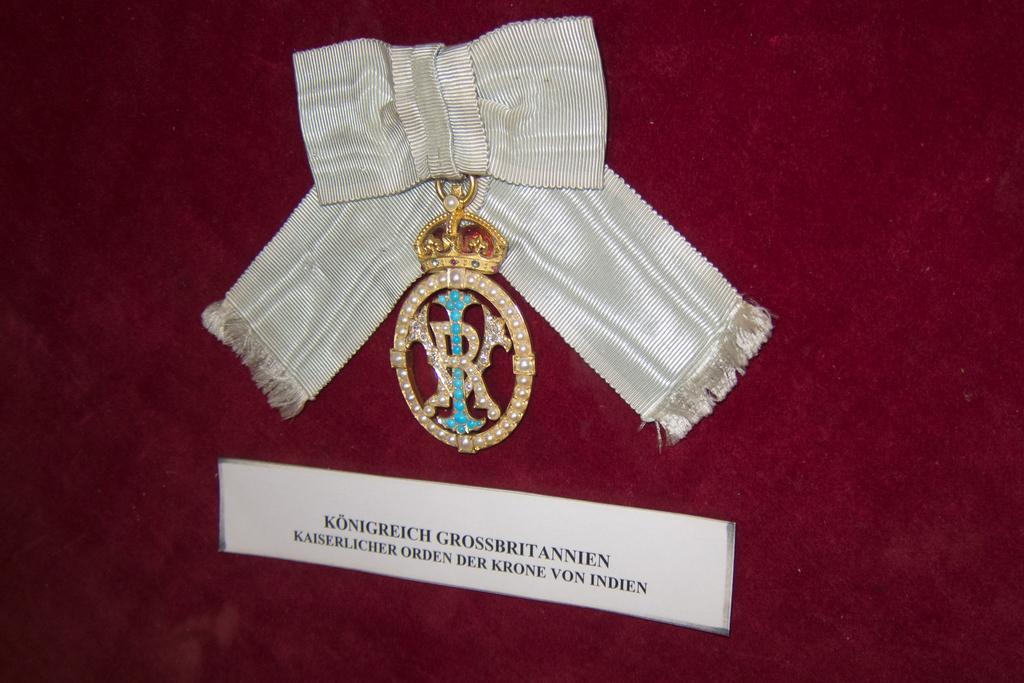Can you describe this image briefly? In this picture I can observe a badge and a ribbon. The badge is hanged on the maroon color surface. I can observe some text on the paper stuck to this surface. 